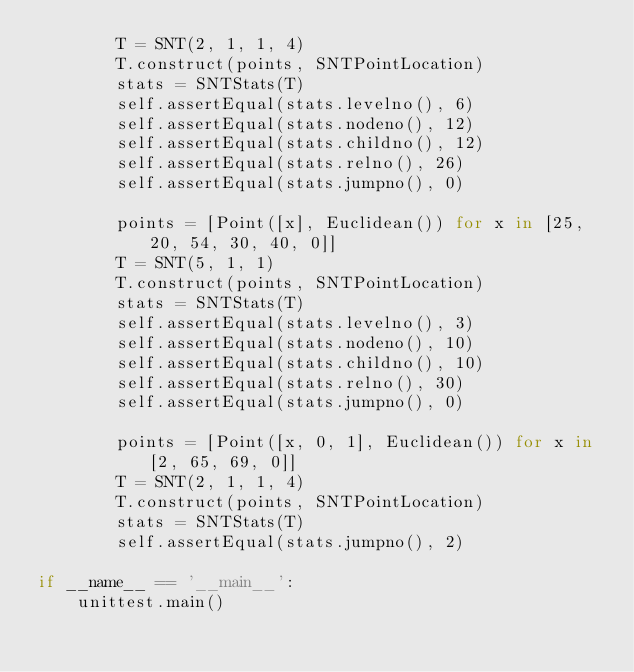Convert code to text. <code><loc_0><loc_0><loc_500><loc_500><_Python_>        T = SNT(2, 1, 1, 4)
        T.construct(points, SNTPointLocation)
        stats = SNTStats(T)
        self.assertEqual(stats.levelno(), 6)
        self.assertEqual(stats.nodeno(), 12)
        self.assertEqual(stats.childno(), 12)
        self.assertEqual(stats.relno(), 26)
        self.assertEqual(stats.jumpno(), 0)
        
        points = [Point([x], Euclidean()) for x in [25, 20, 54, 30, 40, 0]]
        T = SNT(5, 1, 1)
        T.construct(points, SNTPointLocation)
        stats = SNTStats(T)
        self.assertEqual(stats.levelno(), 3)
        self.assertEqual(stats.nodeno(), 10)
        self.assertEqual(stats.childno(), 10)
        self.assertEqual(stats.relno(), 30)
        self.assertEqual(stats.jumpno(), 0)
        
        points = [Point([x, 0, 1], Euclidean()) for x in [2, 65, 69, 0]]
        T = SNT(2, 1, 1, 4)
        T.construct(points, SNTPointLocation)
        stats = SNTStats(T)
        self.assertEqual(stats.jumpno(), 2)
    
if __name__ == '__main__':
    unittest.main()
    
</code> 